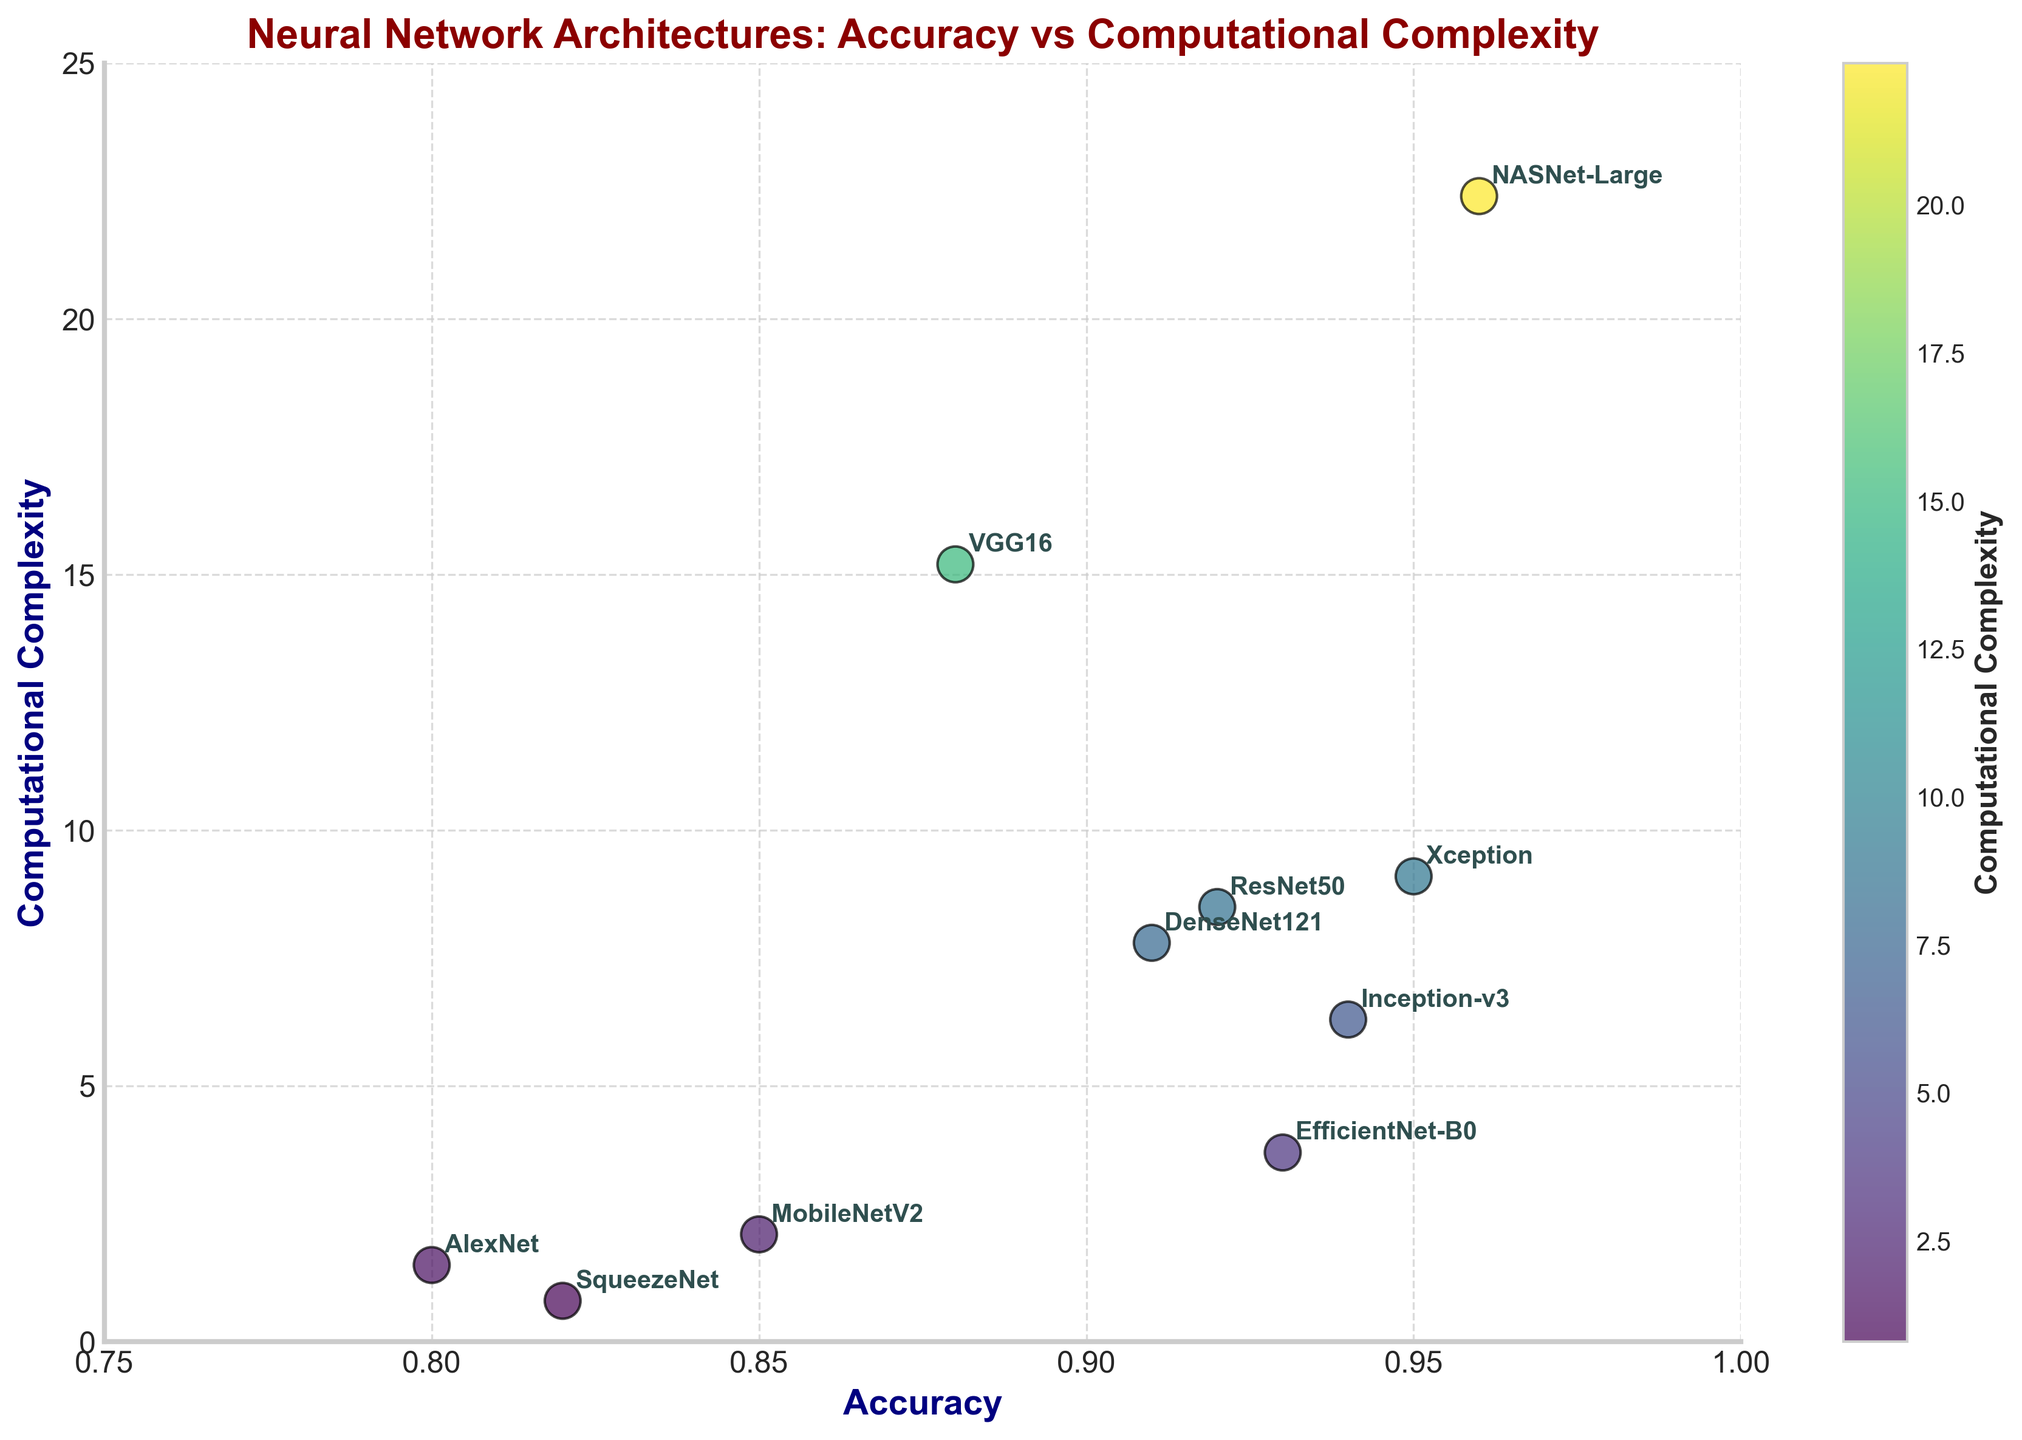Which neural network architecture has the highest computational complexity? By examining the y-axis, which represents computational complexity, we can see that the architecture with the highest value on the y-axis is NASNet-Large.
Answer: NASNet-Large Which architecture has the lowest accuracy? The architecture with the lowest accuracy is identified by finding the lowest value on the x-axis. AlexNet is the architecture with an accuracy of 0.80, the lowest in the plot.
Answer: AlexNet Which neural network offers the highest accuracy while having computational complexity below 10? The plot shows multiple architectures, but the one with the highest accuracy with computational complexity below 10 is Xception, with an accuracy of 0.95.
Answer: Xception What is the range of computational complexities for the listed architectures? The range is calculated by subtracting the smallest y-axis value from the largest y-axis value. The smallest complexity is 0.8 (SqueezeNet) and the largest is 22.4 (NASNet-Large), giving a range of 22.4 - 0.8 = 21.6.
Answer: 21.6 Which architectures have both accuracy greater than 0.90 and computational complexity less than 10? By examining the coordinates that meet the criteria (accuracy > 0.90 and computational complexity < 10), the architectures that meet these conditions are ResNet50, DenseNet121, Inception-v3, and EfficientNet-B0.
Answer: ResNet50, DenseNet121, Inception-v3, EfficientNet-B0 Compare the computational complexity of VGG16 and MobileNetV2. Which one is higher? To find which has higher computational complexity, compare their y-axis values. VGG16 has a complexity of 15.2, while MobileNetV2 has 2.1. Hence, VGG16 has a higher computational complexity.
Answer: VGG16 What is the average accuracy of all architectures shown in the plot? To calculate the average accuracy, sum all accuracies and divide by the number of architectures. (Accuracy sum = 0.92 + 0.88 + 0.94 + 0.91 + 0.85 + 0.93 + 0.80 + 0.82 + 0.95 + 0.96) / 10 architectures = 8.96 / 10 = 0.896.
Answer: 0.896 Out of all the architectures, which one is the most computationally efficient while maintaining accuracy above 0.90? SqueezeNet has the lowest computational complexity (0.8). However, for accuracy above 0.90, EfficientNet-B0 maintains accuracy at 0.93 with a complexity of 3.7, which is the lowest available under these criteria.
Answer: EfficientNet-B0 